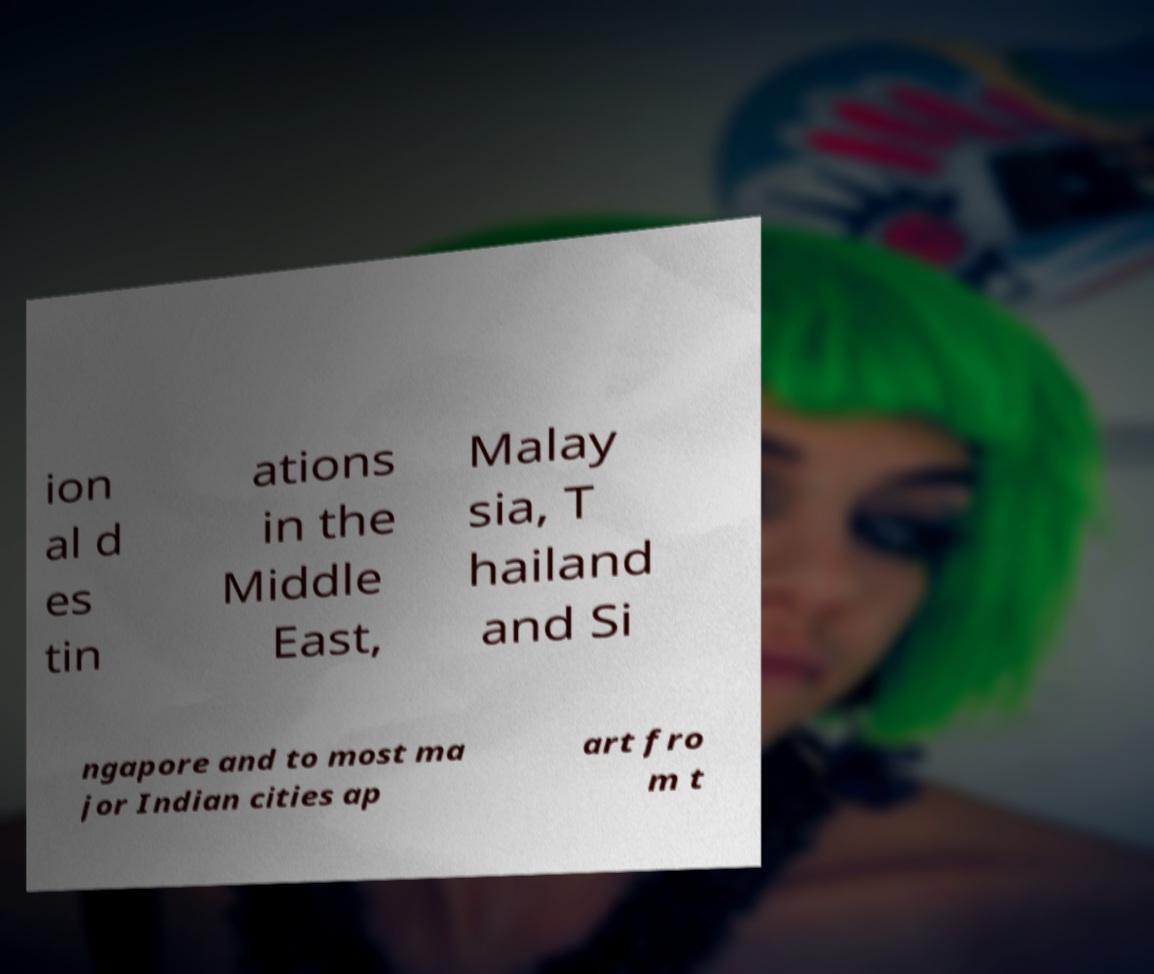Can you read and provide the text displayed in the image?This photo seems to have some interesting text. Can you extract and type it out for me? ion al d es tin ations in the Middle East, Malay sia, T hailand and Si ngapore and to most ma jor Indian cities ap art fro m t 